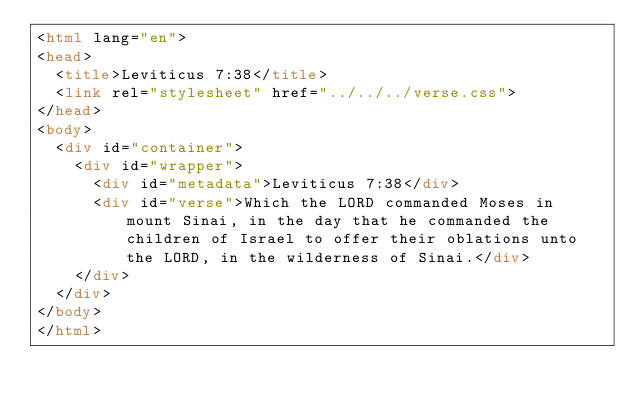Convert code to text. <code><loc_0><loc_0><loc_500><loc_500><_HTML_><html lang="en">
<head>
  <title>Leviticus 7:38</title>
  <link rel="stylesheet" href="../../../verse.css">
</head>
<body>
  <div id="container">
    <div id="wrapper">
      <div id="metadata">Leviticus 7:38</div>
      <div id="verse">Which the LORD commanded Moses in mount Sinai, in the day that he commanded the children of Israel to offer their oblations unto the LORD, in the wilderness of Sinai.</div>
    </div>
  </div>
</body>
</html></code> 